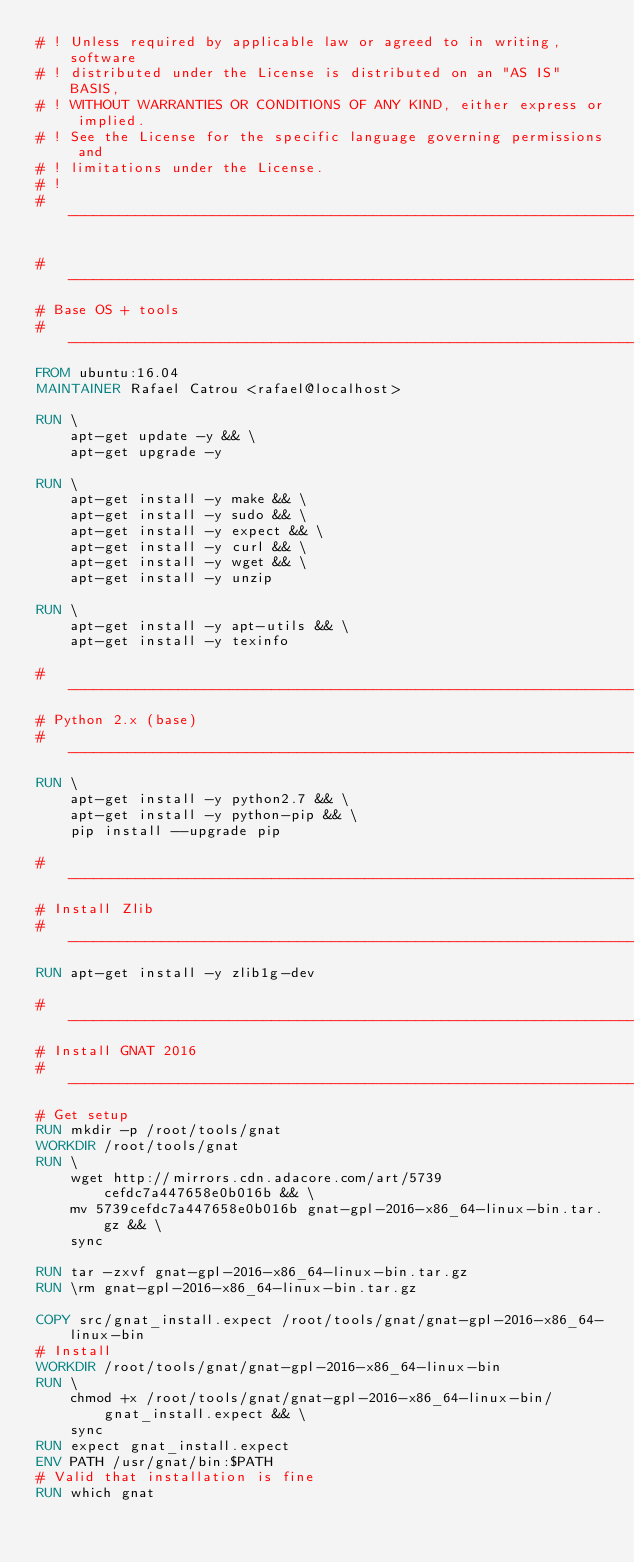Convert code to text. <code><loc_0><loc_0><loc_500><loc_500><_Dockerfile_># ! Unless required by applicable law or agreed to in writing, software
# ! distributed under the License is distributed on an "AS IS" BASIS,
# ! WITHOUT WARRANTIES OR CONDITIONS OF ANY KIND, either express or implied.
# ! See the License for the specific language governing permissions and
# ! limitations under the License.
# !
# --------------------------------------------------------------------------------------------------

# --------------------------------------------------------------------------------------------------
# Base OS + tools
# --------------------------------------------------------------------------------------------------
FROM ubuntu:16.04
MAINTAINER Rafael Catrou <rafael@localhost>

RUN \
    apt-get update -y && \
    apt-get upgrade -y

RUN \
    apt-get install -y make && \
    apt-get install -y sudo && \    
    apt-get install -y expect && \
    apt-get install -y curl && \
    apt-get install -y wget && \
    apt-get install -y unzip

RUN \
    apt-get install -y apt-utils && \
    apt-get install -y texinfo

# --------------------------------------------------------------------------------------------------
# Python 2.x (base)
# --------------------------------------------------------------------------------------------------
RUN \
    apt-get install -y python2.7 && \
    apt-get install -y python-pip && \
    pip install --upgrade pip

# --------------------------------------------------------------------------------------------------
# Install Zlib
# --------------------------------------------------------------------------------------------------
RUN apt-get install -y zlib1g-dev

# --------------------------------------------------------------------------------------------------
# Install GNAT 2016
# --------------------------------------------------------------------------------------------------
# Get setup
RUN mkdir -p /root/tools/gnat
WORKDIR /root/tools/gnat
RUN \
    wget http://mirrors.cdn.adacore.com/art/5739cefdc7a447658e0b016b && \
    mv 5739cefdc7a447658e0b016b gnat-gpl-2016-x86_64-linux-bin.tar.gz && \
    sync

RUN tar -zxvf gnat-gpl-2016-x86_64-linux-bin.tar.gz
RUN \rm gnat-gpl-2016-x86_64-linux-bin.tar.gz

COPY src/gnat_install.expect /root/tools/gnat/gnat-gpl-2016-x86_64-linux-bin
# Install
WORKDIR /root/tools/gnat/gnat-gpl-2016-x86_64-linux-bin
RUN \
    chmod +x /root/tools/gnat/gnat-gpl-2016-x86_64-linux-bin/gnat_install.expect && \
    sync
RUN expect gnat_install.expect
ENV PATH /usr/gnat/bin:$PATH
# Valid that installation is fine
RUN which gnat

</code> 